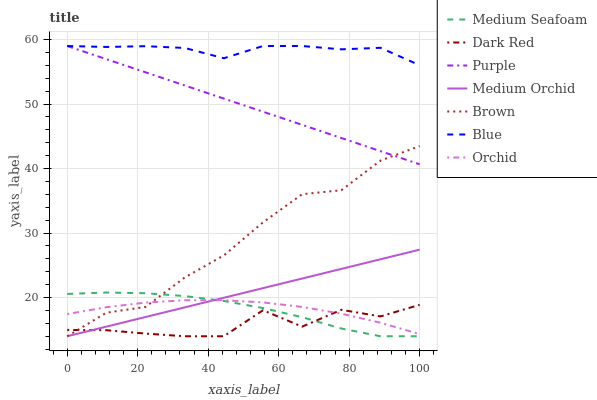Does Dark Red have the minimum area under the curve?
Answer yes or no. Yes. Does Blue have the maximum area under the curve?
Answer yes or no. Yes. Does Brown have the minimum area under the curve?
Answer yes or no. No. Does Brown have the maximum area under the curve?
Answer yes or no. No. Is Medium Orchid the smoothest?
Answer yes or no. Yes. Is Dark Red the roughest?
Answer yes or no. Yes. Is Brown the smoothest?
Answer yes or no. No. Is Brown the roughest?
Answer yes or no. No. Does Brown have the lowest value?
Answer yes or no. Yes. Does Purple have the lowest value?
Answer yes or no. No. Does Purple have the highest value?
Answer yes or no. Yes. Does Brown have the highest value?
Answer yes or no. No. Is Medium Seafoam less than Blue?
Answer yes or no. Yes. Is Purple greater than Orchid?
Answer yes or no. Yes. Does Orchid intersect Dark Red?
Answer yes or no. Yes. Is Orchid less than Dark Red?
Answer yes or no. No. Is Orchid greater than Dark Red?
Answer yes or no. No. Does Medium Seafoam intersect Blue?
Answer yes or no. No. 